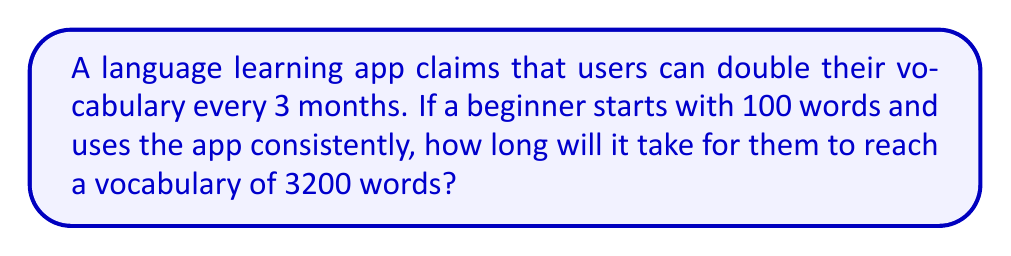What is the answer to this math problem? Let's approach this step-by-step:

1) First, we need to set up our equation. Let $t$ be the time in months and $3200$ be the final vocabulary size:

   $100 \cdot 2^{t/3} = 3200$

2) We can solve this using logarithms. Let's apply $\log_2$ to both sides:

   $\log_2(100 \cdot 2^{t/3}) = \log_2(3200)$

3) Using the logarithm property $\log_a(x \cdot y) = \log_a(x) + \log_a(y)$:

   $\log_2(100) + \log_2(2^{t/3}) = \log_2(3200)$

4) Simplify $\log_2(2^{t/3})$ using the power property of logarithms:

   $\log_2(100) + \frac{t}{3} = \log_2(3200)$

5) Now, let's calculate the logarithms:

   $\log_2(100) \approx 6.64$ (as $2^6 = 64$ and $2^7 = 128$)
   $\log_2(3200) = \log_2(100 \cdot 32) = \log_2(100) + \log_2(32) = 6.64 + 5 = 11.64$

6) Substituting these values:

   $6.64 + \frac{t}{3} = 11.64$

7) Solve for $t$:

   $\frac{t}{3} = 11.64 - 6.64 = 5$
   $t = 5 \cdot 3 = 15$

Therefore, it will take 15 months to reach a vocabulary of 3200 words.
Answer: 15 months 